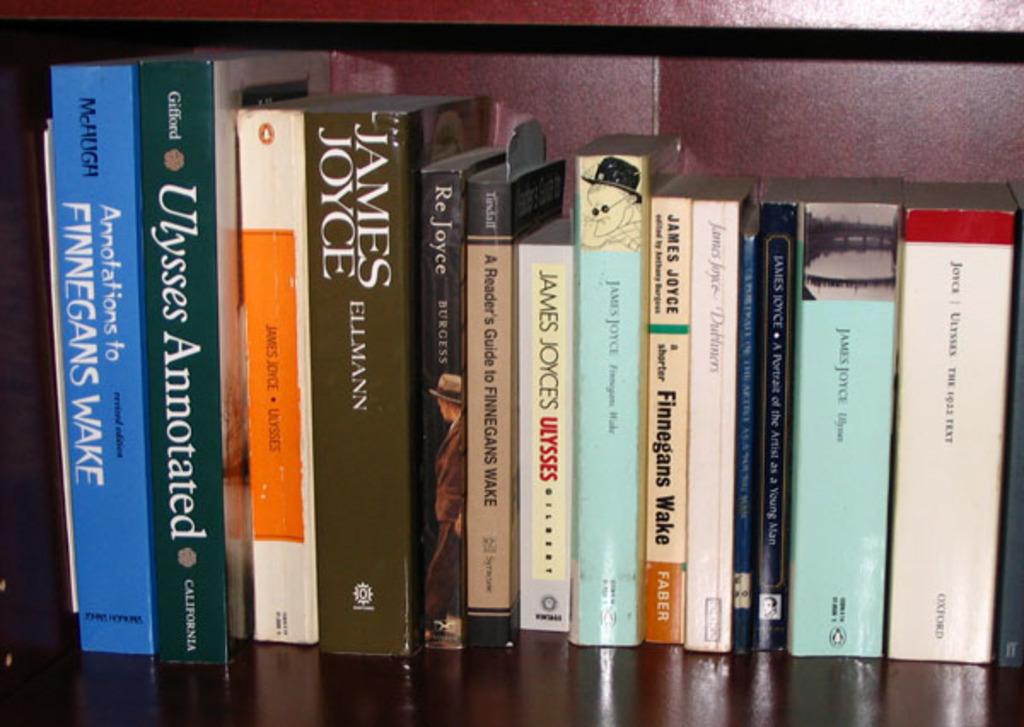Which is the book on ulyesses?
Make the answer very short. Ulysses annotated. What is the book title of blue book?
Provide a short and direct response. Finnegans wake. 